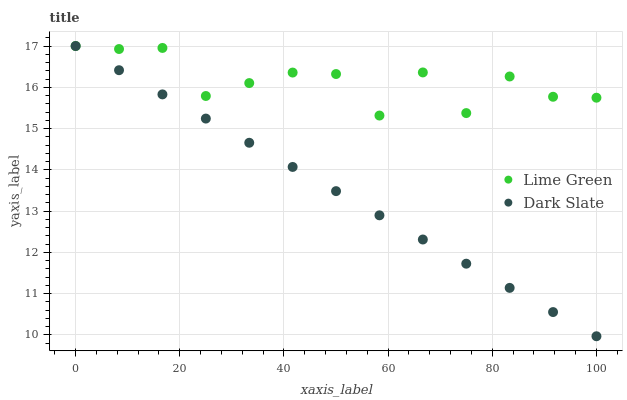Does Dark Slate have the minimum area under the curve?
Answer yes or no. Yes. Does Lime Green have the maximum area under the curve?
Answer yes or no. Yes. Does Lime Green have the minimum area under the curve?
Answer yes or no. No. Is Dark Slate the smoothest?
Answer yes or no. Yes. Is Lime Green the roughest?
Answer yes or no. Yes. Is Lime Green the smoothest?
Answer yes or no. No. Does Dark Slate have the lowest value?
Answer yes or no. Yes. Does Lime Green have the lowest value?
Answer yes or no. No. Does Lime Green have the highest value?
Answer yes or no. Yes. Does Dark Slate intersect Lime Green?
Answer yes or no. Yes. Is Dark Slate less than Lime Green?
Answer yes or no. No. Is Dark Slate greater than Lime Green?
Answer yes or no. No. 